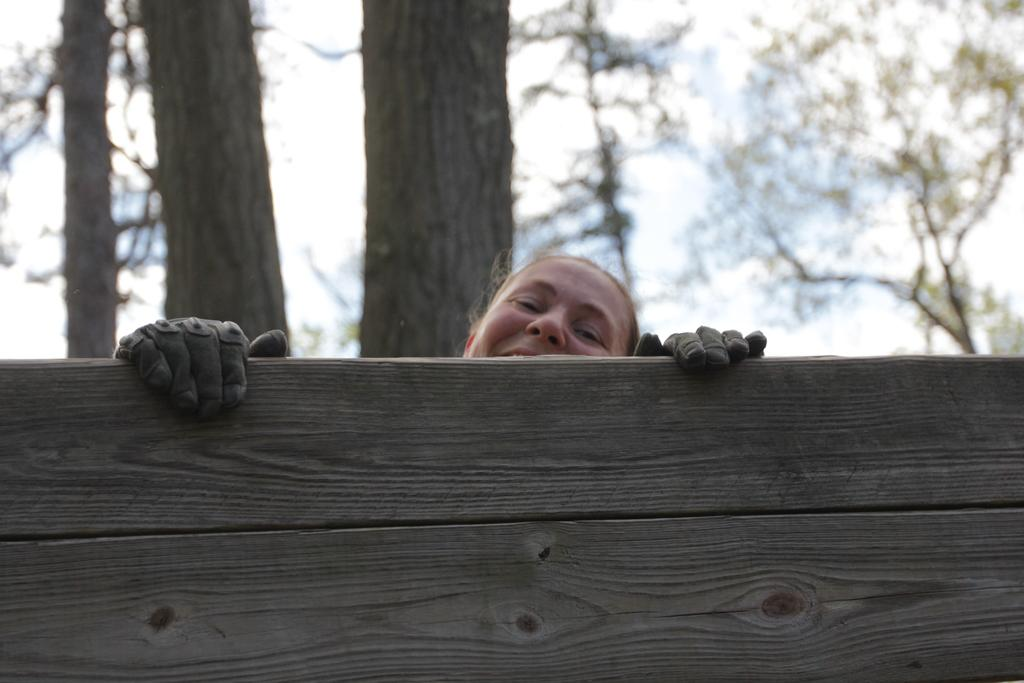What is the person in the image doing? The person is behind a wooden plank in the image. What can be seen in the distance behind the person? There are trees in the background of the image. How would you describe the quality of the background in the image? The background of the image is slightly blurred. What type of record is being played in the image? There is no record present in the image. How does the bee interact with the wooden plank in the image? There is no bee present in the image. 